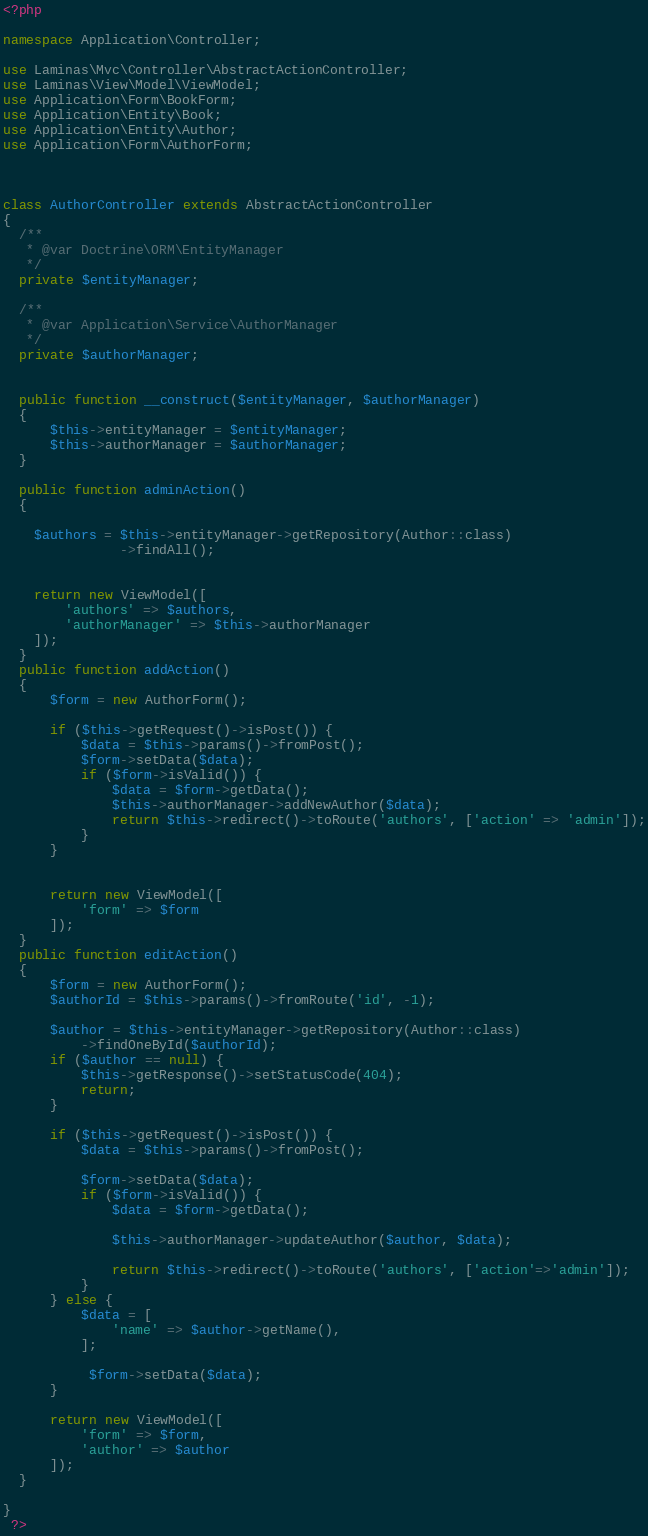<code> <loc_0><loc_0><loc_500><loc_500><_PHP_><?php

namespace Application\Controller;

use Laminas\Mvc\Controller\AbstractActionController;
use Laminas\View\Model\ViewModel;
use Application\Form\BookForm;
use Application\Entity\Book;
use Application\Entity\Author;
use Application\Form\AuthorForm;



class AuthorController extends AbstractActionController
{
  /**
   * @var Doctrine\ORM\EntityManager
   */
  private $entityManager;

  /**
   * @var Application\Service\AuthorManager
   */
  private $authorManager;


  public function __construct($entityManager, $authorManager)
  {
      $this->entityManager = $entityManager;
      $this->authorManager = $authorManager;
  }

  public function adminAction()
  {

    $authors = $this->entityManager->getRepository(Author::class)
               ->findAll();


    return new ViewModel([
        'authors' => $authors,
        'authorManager' => $this->authorManager
    ]);
  }
  public function addAction()
  {
      $form = new AuthorForm();

      if ($this->getRequest()->isPost()) {
          $data = $this->params()->fromPost();
          $form->setData($data);
          if ($form->isValid()) {
              $data = $form->getData();
              $this->authorManager->addNewAuthor($data);
              return $this->redirect()->toRoute('authors', ['action' => 'admin']);
          }
      }


      return new ViewModel([
          'form' => $form
      ]);
  }
  public function editAction()
  {
      $form = new AuthorForm();
      $authorId = $this->params()->fromRoute('id', -1);

      $author = $this->entityManager->getRepository(Author::class)
          ->findOneById($authorId);
      if ($author == null) {
          $this->getResponse()->setStatusCode(404);
          return;
      }

      if ($this->getRequest()->isPost()) {
          $data = $this->params()->fromPost();

          $form->setData($data);
          if ($form->isValid()) {
              $data = $form->getData();

              $this->authorManager->updateAuthor($author, $data);

              return $this->redirect()->toRoute('authors', ['action'=>'admin']);
          }
      } else {
          $data = [
              'name' => $author->getName(),
          ];

           $form->setData($data);
      }

      return new ViewModel([
          'form' => $form,
          'author' => $author
      ]);
  }

}
 ?>
</code> 